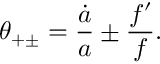Convert formula to latex. <formula><loc_0><loc_0><loc_500><loc_500>\theta _ { + \pm } = { \frac { \dot { a } } { a } } \pm { \frac { f ^ { \prime } } { f } } .</formula> 